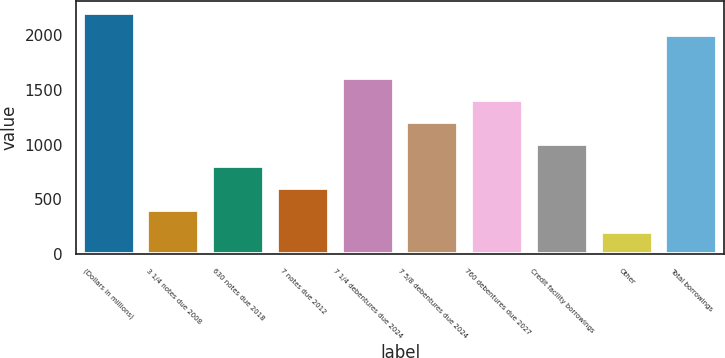Convert chart. <chart><loc_0><loc_0><loc_500><loc_500><bar_chart><fcel>(Dollars in millions)<fcel>3 1/4 notes due 2008<fcel>630 notes due 2018<fcel>7 notes due 2012<fcel>7 1/4 debentures due 2024<fcel>7 5/8 debentures due 2024<fcel>760 debentures due 2027<fcel>Credit facility borrowings<fcel>Other<fcel>Total borrowings<nl><fcel>2206.3<fcel>403.6<fcel>804.2<fcel>603.9<fcel>1605.4<fcel>1204.8<fcel>1405.1<fcel>1004.5<fcel>203.3<fcel>2006<nl></chart> 